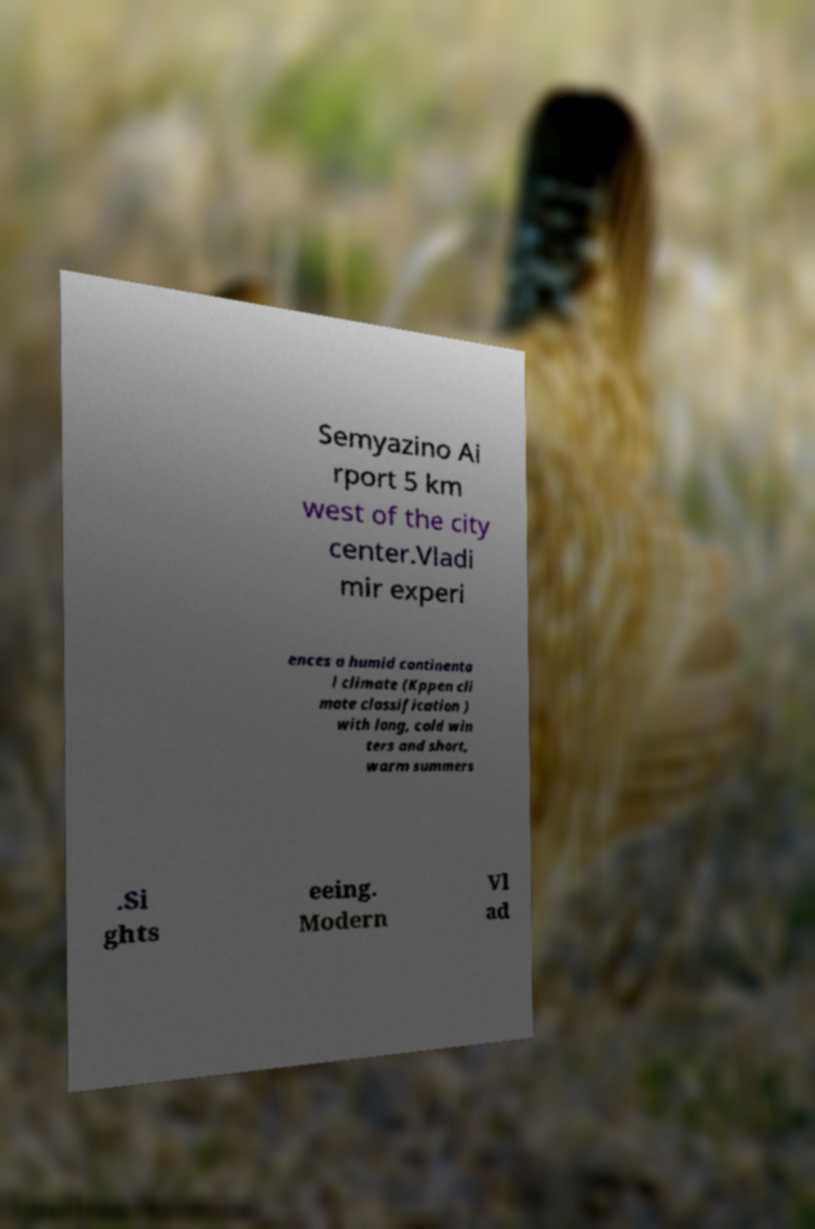Can you read and provide the text displayed in the image?This photo seems to have some interesting text. Can you extract and type it out for me? Semyazino Ai rport 5 km west of the city center.Vladi mir experi ences a humid continenta l climate (Kppen cli mate classification ) with long, cold win ters and short, warm summers .Si ghts eeing. Modern Vl ad 